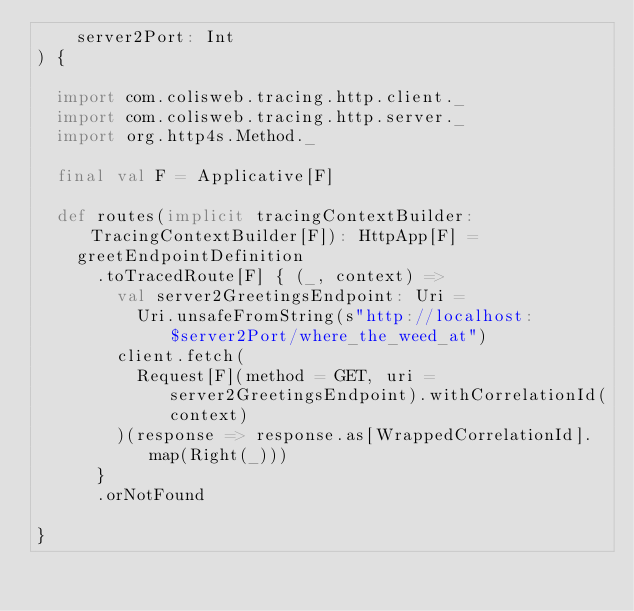<code> <loc_0><loc_0><loc_500><loc_500><_Scala_>    server2Port: Int
) {

  import com.colisweb.tracing.http.client._
  import com.colisweb.tracing.http.server._
  import org.http4s.Method._

  final val F = Applicative[F]

  def routes(implicit tracingContextBuilder: TracingContextBuilder[F]): HttpApp[F] =
    greetEndpointDefinition
      .toTracedRoute[F] { (_, context) =>
        val server2GreetingsEndpoint: Uri =
          Uri.unsafeFromString(s"http://localhost:$server2Port/where_the_weed_at")
        client.fetch(
          Request[F](method = GET, uri = server2GreetingsEndpoint).withCorrelationId(context)
        )(response => response.as[WrappedCorrelationId].map(Right(_)))
      }
      .orNotFound

}
</code> 